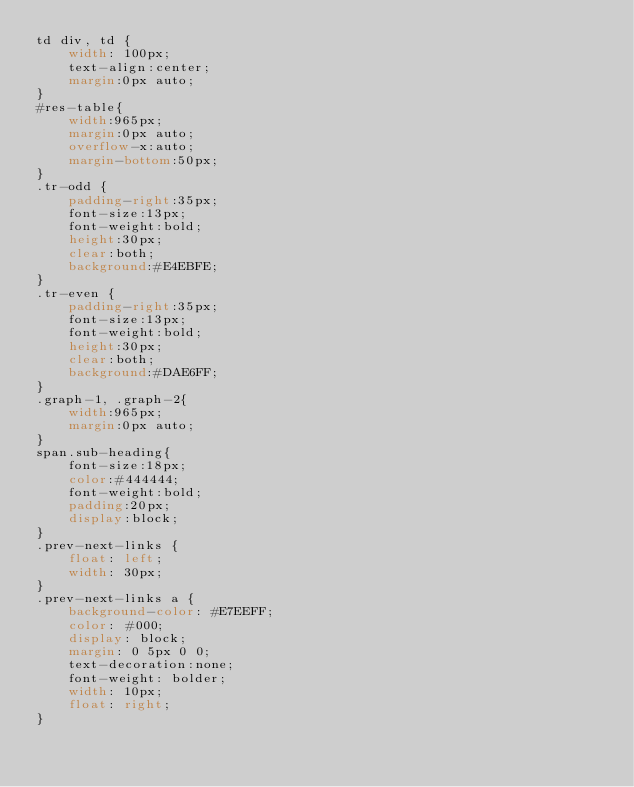<code> <loc_0><loc_0><loc_500><loc_500><_CSS_>td div, td {
    width: 100px;
    text-align:center;
    margin:0px auto;
}
#res-table{
    width:965px;
    margin:0px auto;
    overflow-x:auto;
    margin-bottom:50px;
}
.tr-odd {
    padding-right:35px;
    font-size:13px;
    font-weight:bold;
    height:30px;
    clear:both;
    background:#E4EBFE;
}
.tr-even {
    padding-right:35px;
    font-size:13px;
    font-weight:bold;
    height:30px;
    clear:both;
    background:#DAE6FF;
}
.graph-1, .graph-2{
    width:965px;
    margin:0px auto;
}
span.sub-heading{
    font-size:18px;
    color:#444444;
    font-weight:bold;
    padding:20px;
    display:block;
}
.prev-next-links {
    float: left;
    width: 30px;
}
.prev-next-links a {
    background-color: #E7EEFF;
    color: #000;
    display: block;
    margin: 0 5px 0 0;
    text-decoration:none;
    font-weight: bolder;
    width: 10px;
    float: right;
}</code> 